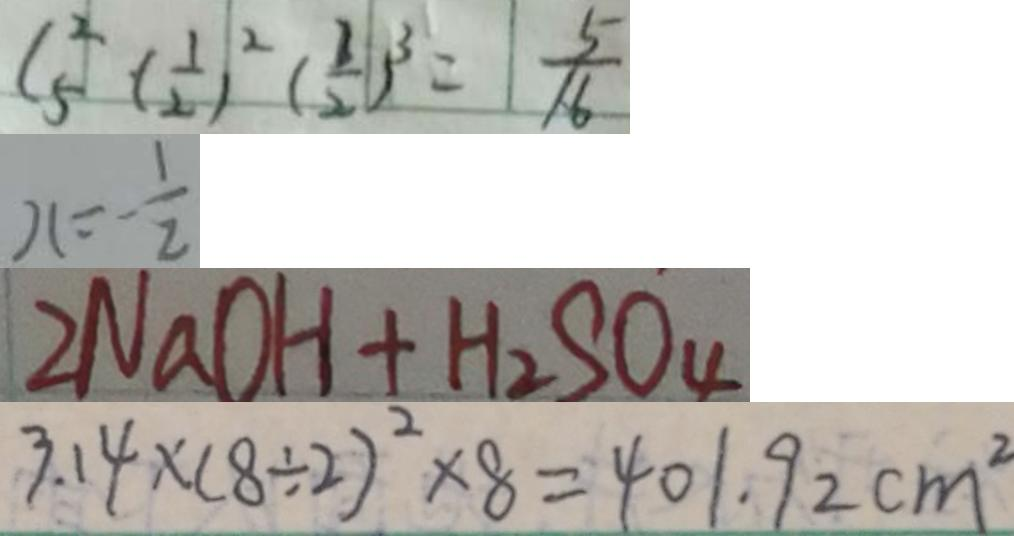<formula> <loc_0><loc_0><loc_500><loc_500>C _ { 5 } ^ { 2 } ( \frac { 1 } { 2 } ) ^ { 2 } ( \frac { 3 } { 2 } ) ^ { 3 } = \frac { 5 } { 1 6 } 
 x = - \frac { 1 } { 2 } 
 2 N a O H + H _ { 2 } S O _ { 4 } 
 3 . 1 4 \times ( 8 \div 2 ) ^ { 2 } \times 8 = 4 0 1 . 9 2 c m ^ { 2 }</formula> 